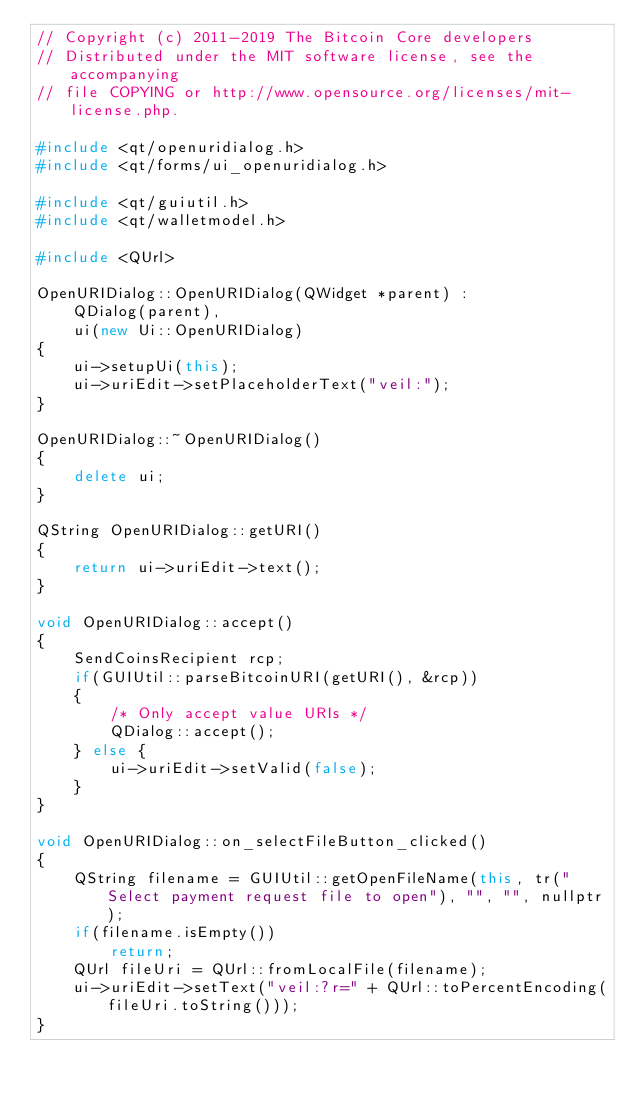Convert code to text. <code><loc_0><loc_0><loc_500><loc_500><_C++_>// Copyright (c) 2011-2019 The Bitcoin Core developers
// Distributed under the MIT software license, see the accompanying
// file COPYING or http://www.opensource.org/licenses/mit-license.php.

#include <qt/openuridialog.h>
#include <qt/forms/ui_openuridialog.h>

#include <qt/guiutil.h>
#include <qt/walletmodel.h>

#include <QUrl>

OpenURIDialog::OpenURIDialog(QWidget *parent) :
    QDialog(parent),
    ui(new Ui::OpenURIDialog)
{
    ui->setupUi(this);
    ui->uriEdit->setPlaceholderText("veil:");
}

OpenURIDialog::~OpenURIDialog()
{
    delete ui;
}

QString OpenURIDialog::getURI()
{
    return ui->uriEdit->text();
}

void OpenURIDialog::accept()
{
    SendCoinsRecipient rcp;
    if(GUIUtil::parseBitcoinURI(getURI(), &rcp))
    {
        /* Only accept value URIs */
        QDialog::accept();
    } else {
        ui->uriEdit->setValid(false);
    }
}

void OpenURIDialog::on_selectFileButton_clicked()
{
    QString filename = GUIUtil::getOpenFileName(this, tr("Select payment request file to open"), "", "", nullptr);
    if(filename.isEmpty())
        return;
    QUrl fileUri = QUrl::fromLocalFile(filename);
    ui->uriEdit->setText("veil:?r=" + QUrl::toPercentEncoding(fileUri.toString()));
}
</code> 